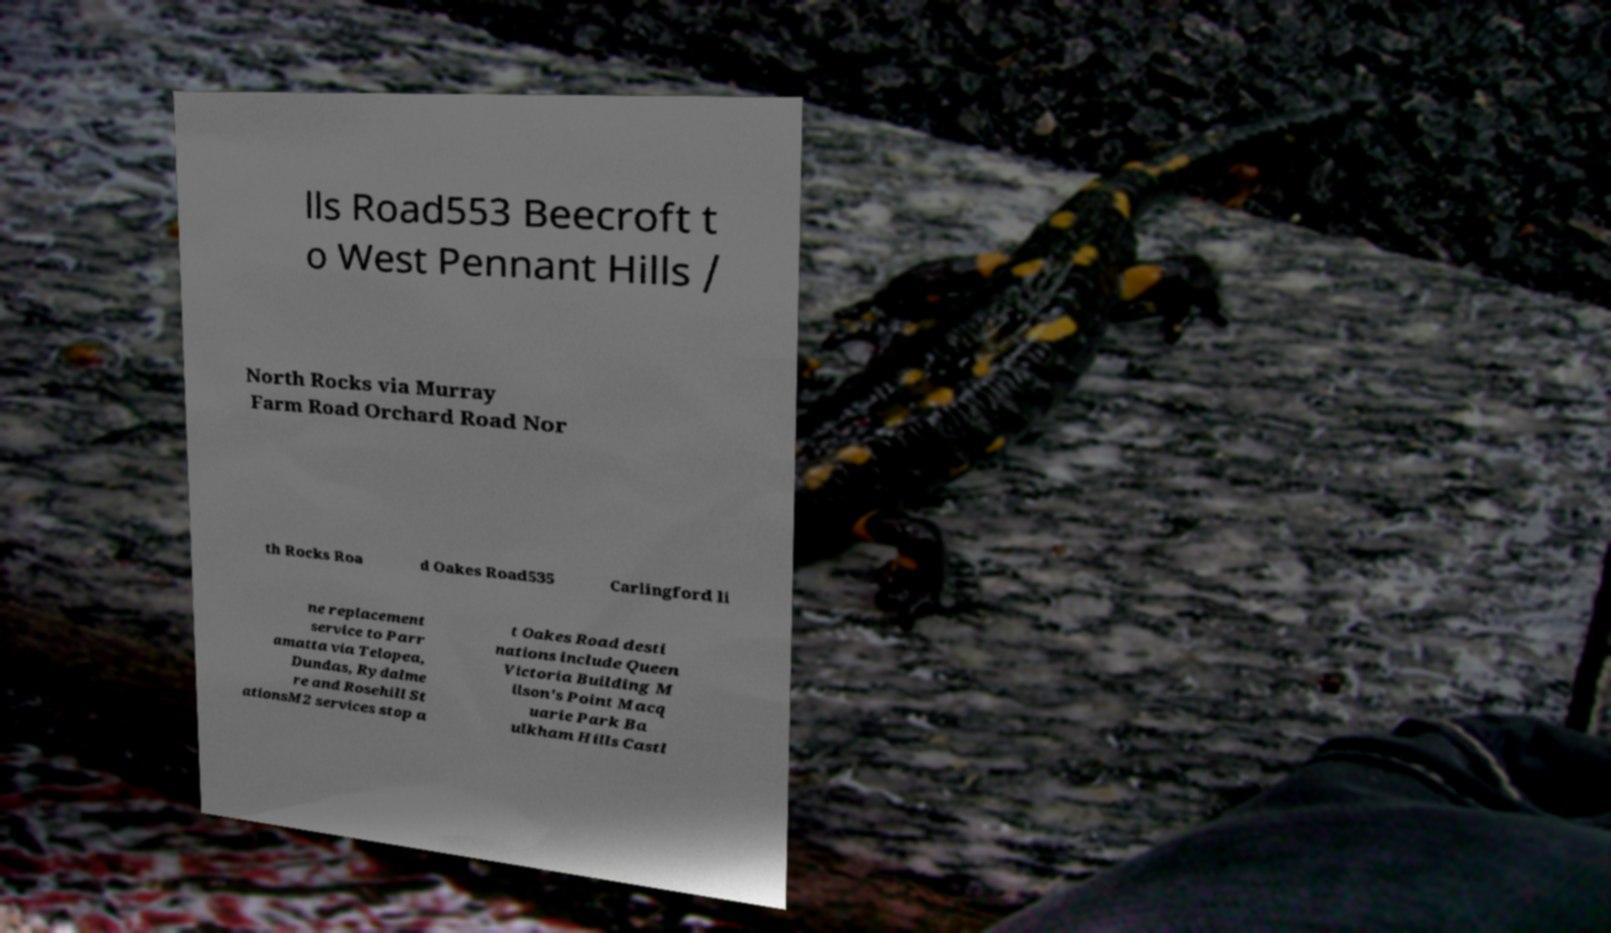What messages or text are displayed in this image? I need them in a readable, typed format. lls Road553 Beecroft t o West Pennant Hills / North Rocks via Murray Farm Road Orchard Road Nor th Rocks Roa d Oakes Road535 Carlingford li ne replacement service to Parr amatta via Telopea, Dundas, Rydalme re and Rosehill St ationsM2 services stop a t Oakes Road desti nations include Queen Victoria Building M ilson's Point Macq uarie Park Ba ulkham Hills Castl 